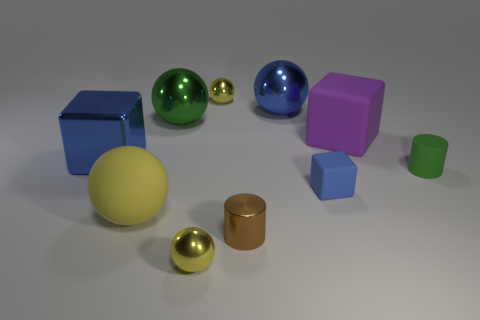There is a small thing that is in front of the green matte thing and right of the small brown metallic thing; what is it made of?
Provide a short and direct response. Rubber. There is a big green object that is made of the same material as the large blue block; what is its shape?
Make the answer very short. Sphere. There is a object that is the same color as the small rubber cylinder; what shape is it?
Offer a very short reply. Sphere. What is the color of the large rubber ball?
Offer a very short reply. Yellow. Does the small rubber cylinder have the same color as the small shiny object behind the purple matte thing?
Offer a very short reply. No. The blue block that is made of the same material as the small brown object is what size?
Offer a very short reply. Large. Are there any large shiny balls of the same color as the tiny metal cylinder?
Your response must be concise. No. Is the green ball made of the same material as the block that is in front of the big blue cube?
Your response must be concise. No. There is a matte thing that is the same color as the shiny block; what is its size?
Offer a very short reply. Small. Are there any brown cylinders made of the same material as the small brown thing?
Offer a terse response. No. 